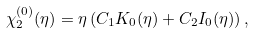<formula> <loc_0><loc_0><loc_500><loc_500>\chi ^ { ( 0 ) } _ { 2 } ( \eta ) = \eta \left ( C _ { 1 } K _ { 0 } ( \eta ) + C _ { 2 } I _ { 0 } ( \eta ) \right ) ,</formula> 